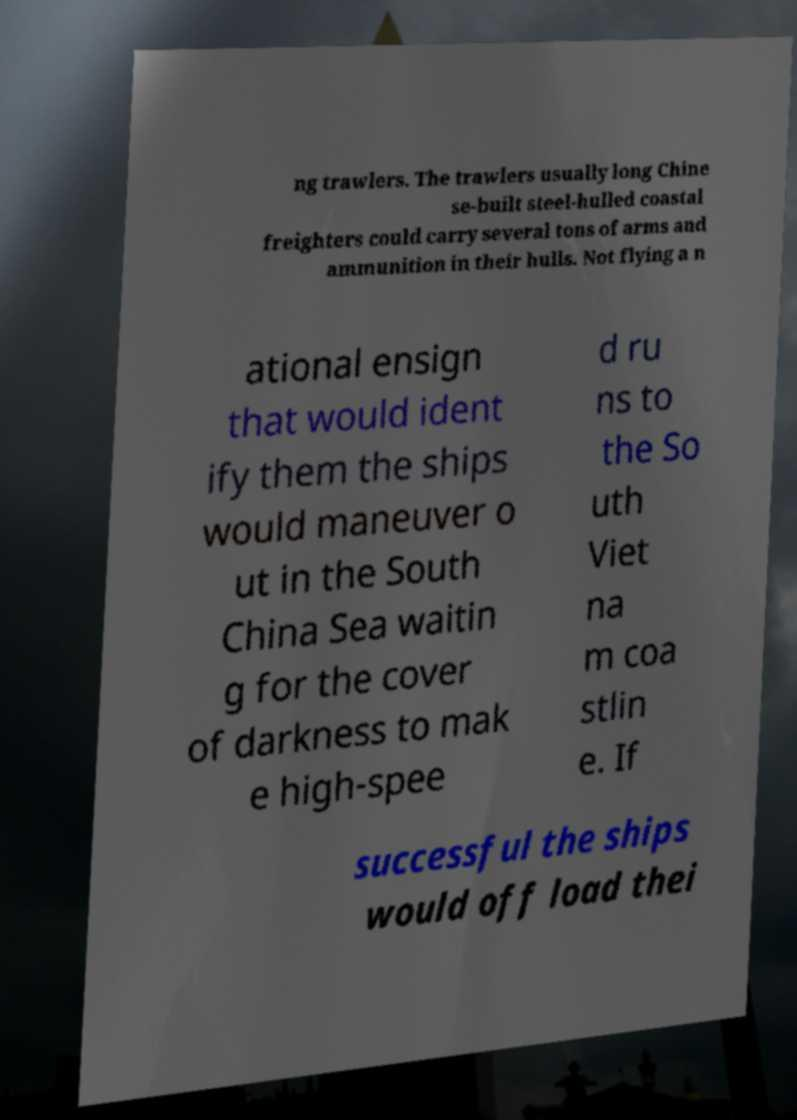Can you read and provide the text displayed in the image?This photo seems to have some interesting text. Can you extract and type it out for me? ng trawlers. The trawlers usually long Chine se-built steel-hulled coastal freighters could carry several tons of arms and ammunition in their hulls. Not flying a n ational ensign that would ident ify them the ships would maneuver o ut in the South China Sea waitin g for the cover of darkness to mak e high-spee d ru ns to the So uth Viet na m coa stlin e. If successful the ships would off load thei 